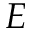<formula> <loc_0><loc_0><loc_500><loc_500>E</formula> 